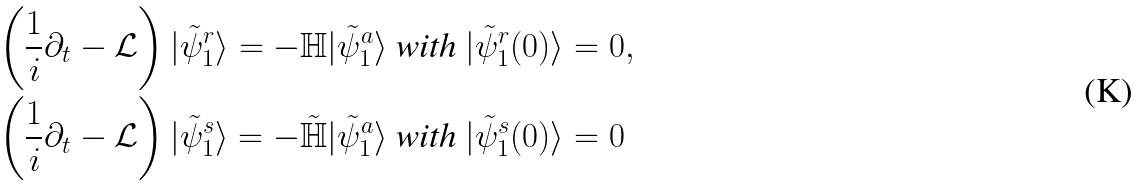<formula> <loc_0><loc_0><loc_500><loc_500>& \left ( \frac { 1 } { i } \partial _ { t } - \mathcal { L } \right ) | \tilde { \psi } _ { 1 } ^ { r } \rangle = - \mathbb { H } | \tilde { \psi } _ { 1 } ^ { a } \rangle \text { with } | \tilde { \psi } _ { 1 } ^ { r } ( 0 ) \rangle = 0 , \\ & \left ( \frac { 1 } { i } \partial _ { t } - \mathcal { L } \right ) | \tilde { \psi } _ { 1 } ^ { s } \rangle = - \tilde { \mathbb { H } } | \tilde { \psi } _ { 1 } ^ { a } \rangle \text { with } | \tilde { \psi } _ { 1 } ^ { s } ( 0 ) \rangle = 0</formula> 